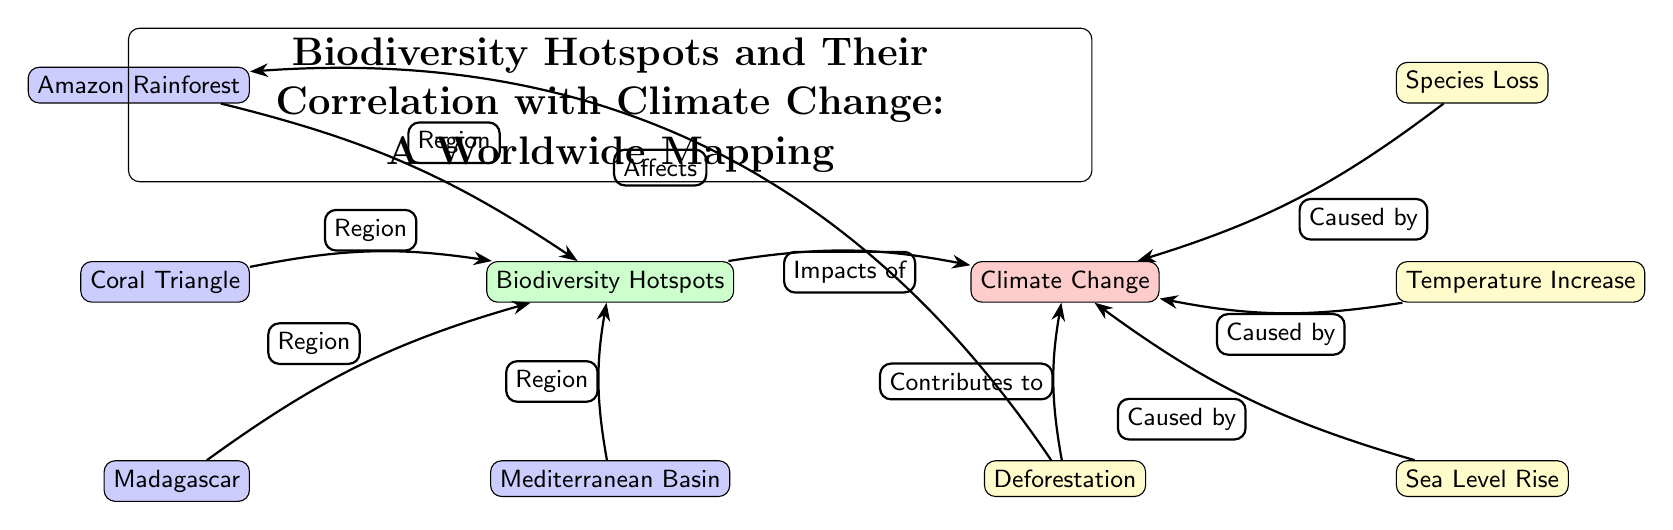What are the biodiversity hotspots shown in the diagram? The diagram lists the biodiversity hotspots as the Amazon Rainforest, Coral Triangle, Madagascar, and Mediterranean Basin, which are specifically indicated as regions connected to the Biodiversity Hotspots node.
Answer: Amazon Rainforest, Coral Triangle, Madagascar, Mediterranean Basin How many regions are connected to the Biodiversity Hotspots? The diagram shows four distinct regions (Amazon Rainforest, Coral Triangle, Madagascar, Mediterranean Basin) that are all connected to the Biodiversity Hotspots node.
Answer: 4 What is the type of relationship between Biodiversity Hotspots and Climate Change? The diagram illustrates that the relationship between Biodiversity Hotspots and Climate Change is indicated by the edge labeled "Impacts of," indicating a direct influence from biodiversity on climate change.
Answer: Impacts of Which effect is related to temperature increase? The diagram clearly places "Temperature Increase" as an effect caused by Climate Change, hence it is directly associated as the specific effect related to temperature.
Answer: Temperature Increase What contributes to climate change according to the diagram? The diagram specifies "Deforestation" as a contributing factor to climate change, which is explicitly labeled in the relationships between the nodes.
Answer: Deforestation How does deforestation affect the Amazon Rainforest? The diagram links "Deforestation" directly to the "Amazon Rainforest" with the label "Affects", indicating the negative impact that deforestation has on this specific biodiversity hotspot.
Answer: Affects Which effect causes species loss? The diagram indicates that "Species Loss" is one of the effects that is caused by Climate Change, which means it directly results from the impacts mentioned in the relationship with climate change.
Answer: Species Loss What regions are connected to the effect of sea level rise? The diagram does not explicitly list any regions that correlate with "Sea Level Rise", indicating that this effect is primarily associated with Climate Change without direct regional linkages shown within the scope of the diagram.
Answer: (No specific region) 